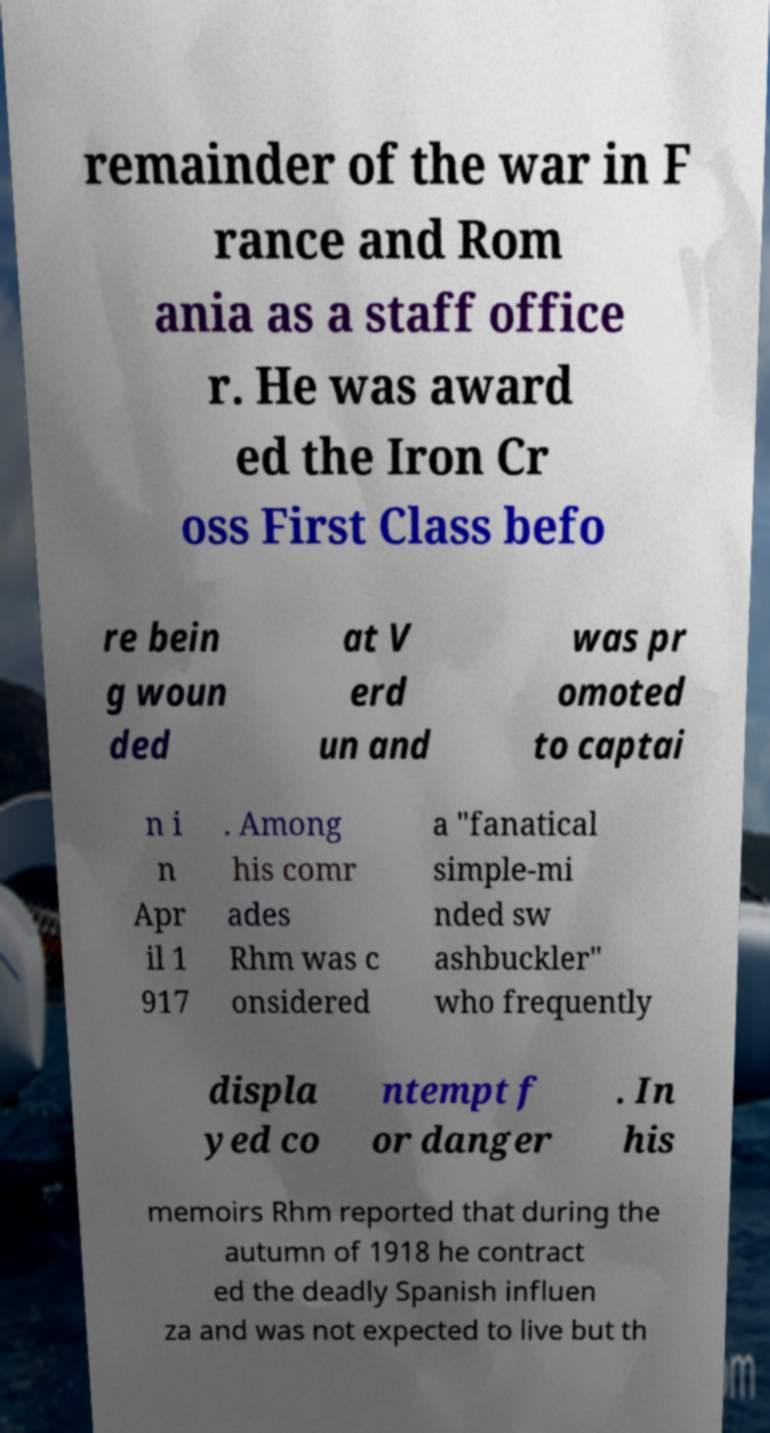There's text embedded in this image that I need extracted. Can you transcribe it verbatim? remainder of the war in F rance and Rom ania as a staff office r. He was award ed the Iron Cr oss First Class befo re bein g woun ded at V erd un and was pr omoted to captai n i n Apr il 1 917 . Among his comr ades Rhm was c onsidered a "fanatical simple-mi nded sw ashbuckler" who frequently displa yed co ntempt f or danger . In his memoirs Rhm reported that during the autumn of 1918 he contract ed the deadly Spanish influen za and was not expected to live but th 